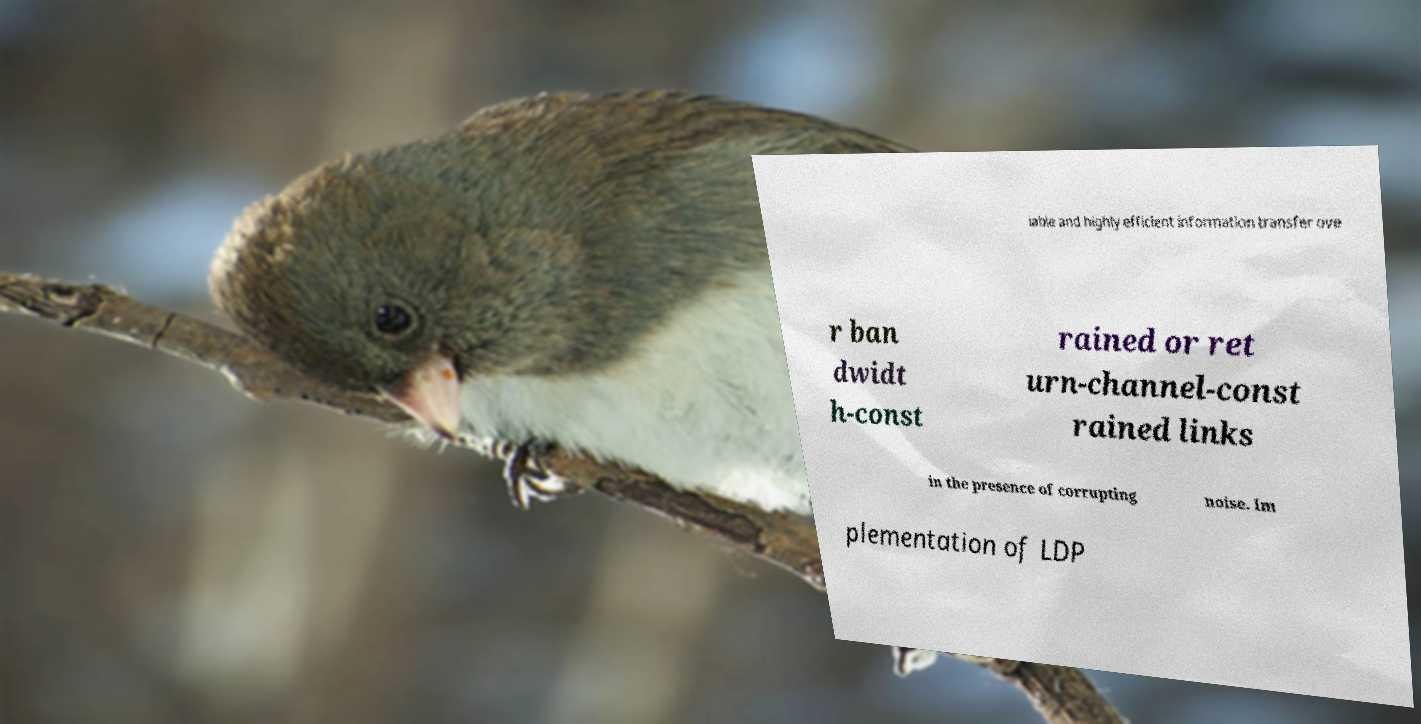Please read and relay the text visible in this image. What does it say? iable and highly efficient information transfer ove r ban dwidt h-const rained or ret urn-channel-const rained links in the presence of corrupting noise. Im plementation of LDP 